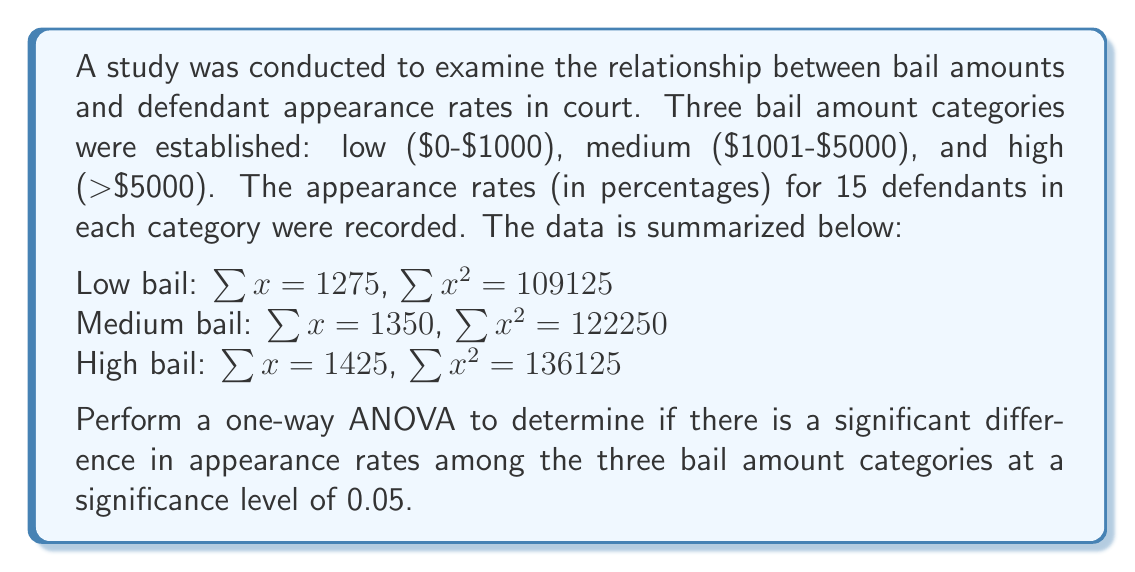Solve this math problem. To perform a one-way ANOVA, we'll follow these steps:

1) Calculate the total sum of squares (SST):
   $$SST = \sum x^2 - \frac{(\sum x)^2}{N}$$
   where $\sum x^2 = 109125 + 122250 + 136125 = 367500$
   and $\sum x = 1275 + 1350 + 1425 = 4050$
   $N = 15 * 3 = 45$

   $$SST = 367500 - \frac{4050^2}{45} = 367500 - 364500 = 3000$$

2) Calculate the between-groups sum of squares (SSB):
   $$SSB = \sum \frac{(\sum x_i)^2}{n_i} - \frac{(\sum x)^2}{N}$$
   where $n_i = 15$ for each group

   $$SSB = \frac{1275^2 + 1350^2 + 1425^2}{15} - \frac{4050^2}{45} = 366250 - 364500 = 1750$$

3) Calculate the within-groups sum of squares (SSW):
   $$SSW = SST - SSB = 3000 - 1750 = 1250$$

4) Calculate degrees of freedom:
   $df_{between} = k - 1 = 3 - 1 = 2$ (where k is the number of groups)
   $df_{within} = N - k = 45 - 3 = 42$
   $df_{total} = N - 1 = 45 - 1 = 44$

5) Calculate mean squares:
   $$MS_{between} = \frac{SSB}{df_{between}} = \frac{1750}{2} = 875$$
   $$MS_{within} = \frac{SSW}{df_{within}} = \frac{1250}{42} = 29.76$$

6) Calculate F-statistic:
   $$F = \frac{MS_{between}}{MS_{within}} = \frac{875}{29.76} = 29.40$$

7) Find the critical F-value:
   With $df_{between} = 2$ and $df_{within} = 42$, and $\alpha = 0.05$,
   $F_{critical} = 3.22$ (from F-distribution table)

8) Make a decision:
   Since $F = 29.40 > F_{critical} = 3.22$, we reject the null hypothesis.
Answer: The one-way ANOVA results in $F(2, 42) = 29.40, p < 0.05$. There is a statistically significant difference in appearance rates among the three bail amount categories at the 0.05 significance level. 